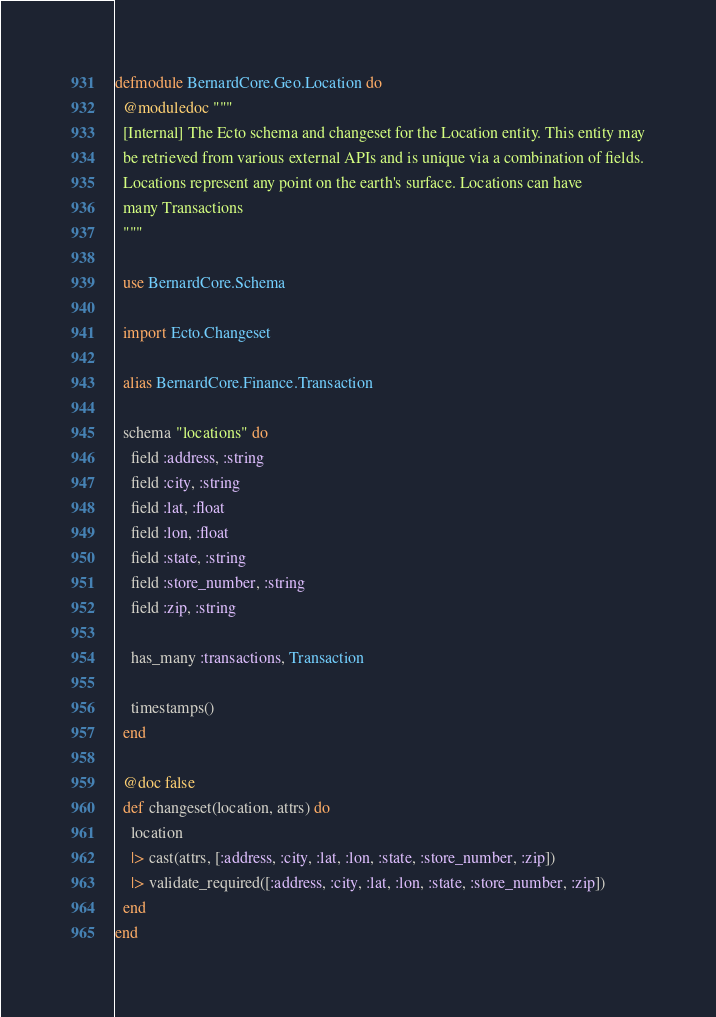Convert code to text. <code><loc_0><loc_0><loc_500><loc_500><_Elixir_>defmodule BernardCore.Geo.Location do
  @moduledoc """
  [Internal] The Ecto schema and changeset for the Location entity. This entity may
  be retrieved from various external APIs and is unique via a combination of fields.
  Locations represent any point on the earth's surface. Locations can have
  many Transactions
  """

  use BernardCore.Schema

  import Ecto.Changeset

  alias BernardCore.Finance.Transaction

  schema "locations" do
    field :address, :string
    field :city, :string
    field :lat, :float
    field :lon, :float
    field :state, :string
    field :store_number, :string
    field :zip, :string

    has_many :transactions, Transaction

    timestamps()
  end

  @doc false
  def changeset(location, attrs) do
    location
    |> cast(attrs, [:address, :city, :lat, :lon, :state, :store_number, :zip])
    |> validate_required([:address, :city, :lat, :lon, :state, :store_number, :zip])
  end
end
</code> 